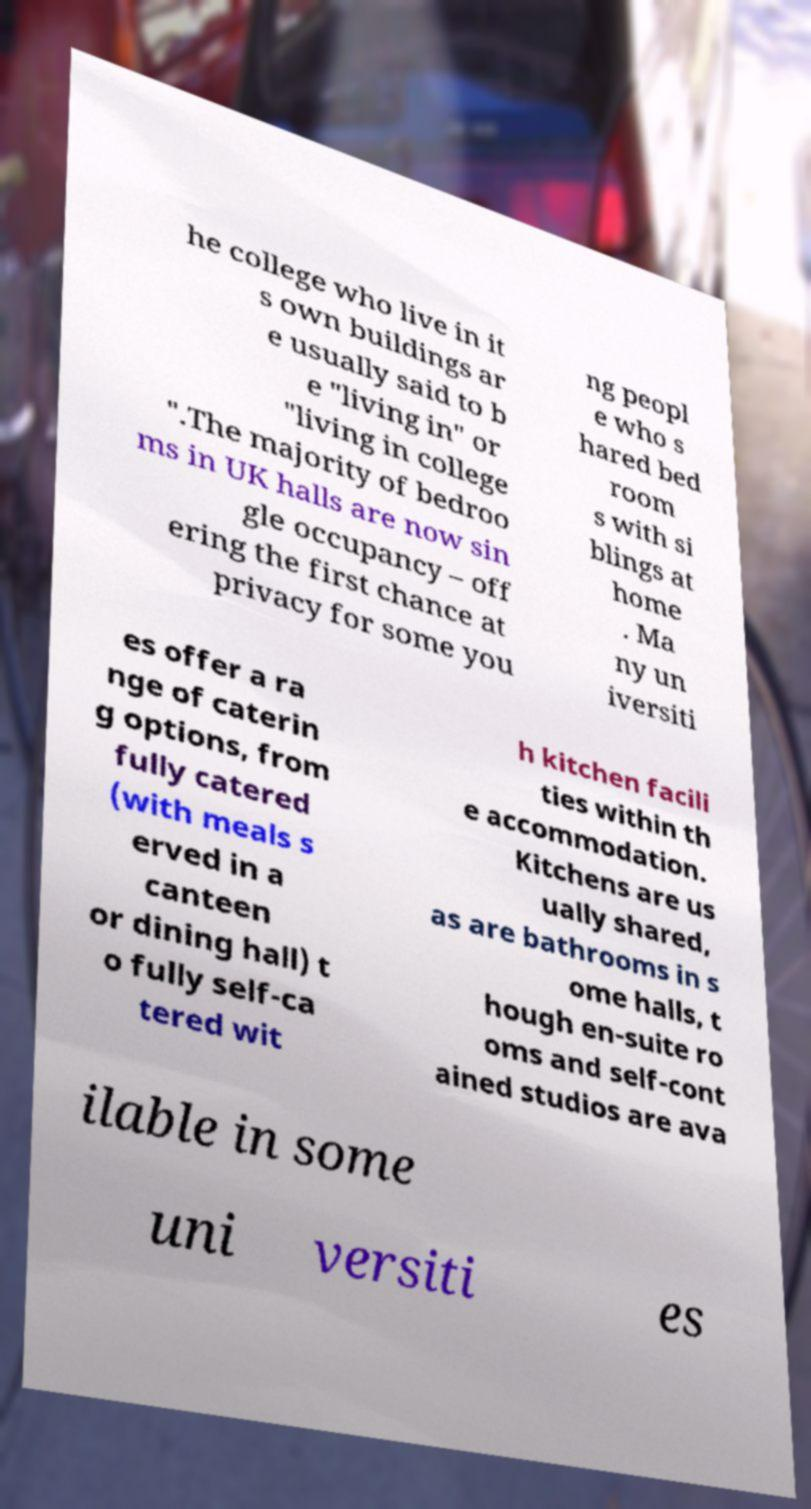For documentation purposes, I need the text within this image transcribed. Could you provide that? he college who live in it s own buildings ar e usually said to b e "living in" or "living in college ".The majority of bedroo ms in UK halls are now sin gle occupancy – off ering the first chance at privacy for some you ng peopl e who s hared bed room s with si blings at home . Ma ny un iversiti es offer a ra nge of caterin g options, from fully catered (with meals s erved in a canteen or dining hall) t o fully self-ca tered wit h kitchen facili ties within th e accommodation. Kitchens are us ually shared, as are bathrooms in s ome halls, t hough en-suite ro oms and self-cont ained studios are ava ilable in some uni versiti es 